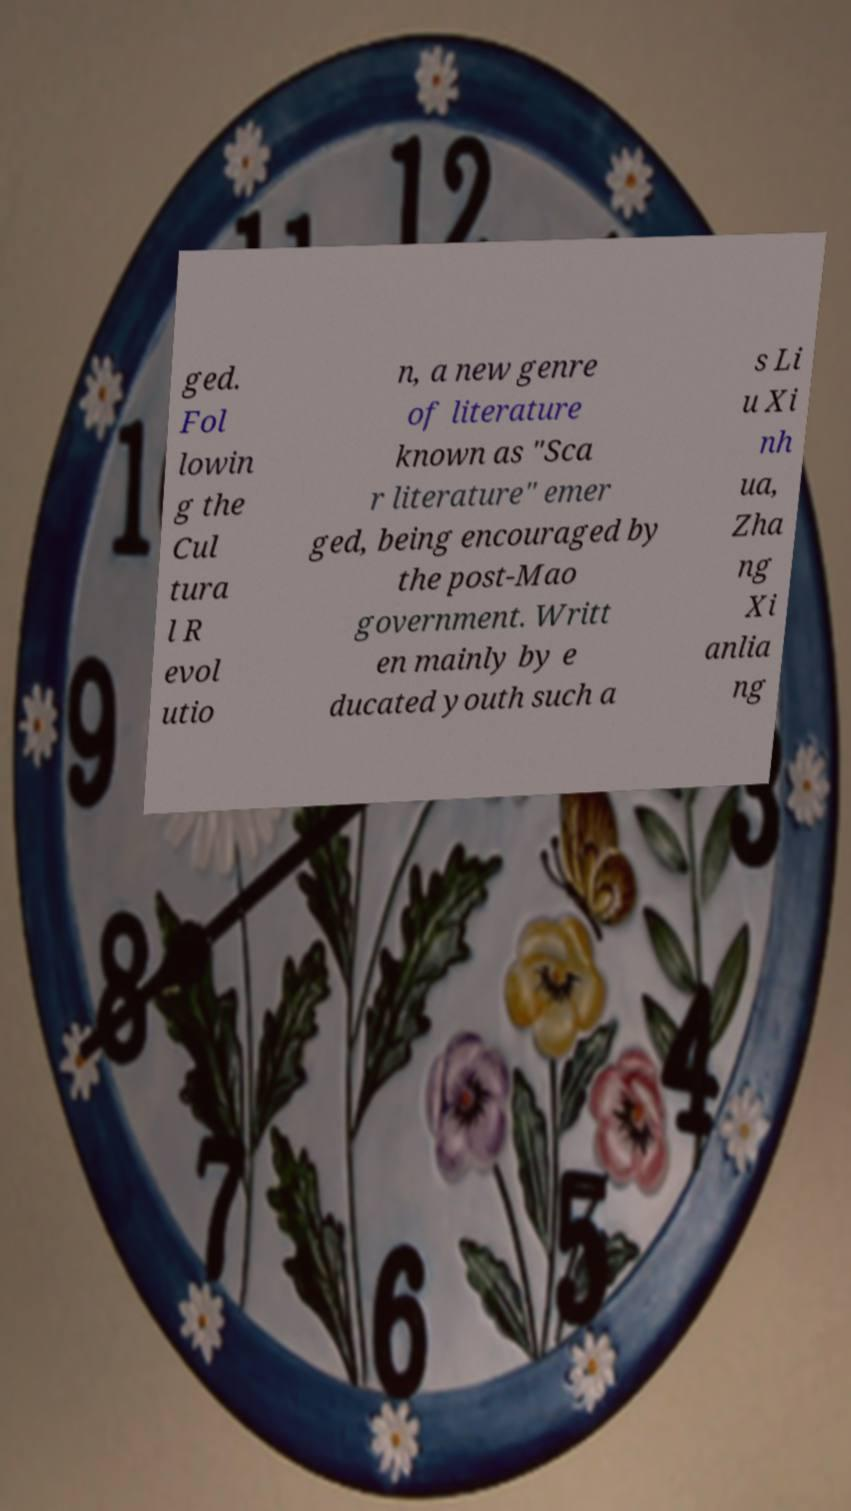For documentation purposes, I need the text within this image transcribed. Could you provide that? ged. Fol lowin g the Cul tura l R evol utio n, a new genre of literature known as "Sca r literature" emer ged, being encouraged by the post-Mao government. Writt en mainly by e ducated youth such a s Li u Xi nh ua, Zha ng Xi anlia ng 